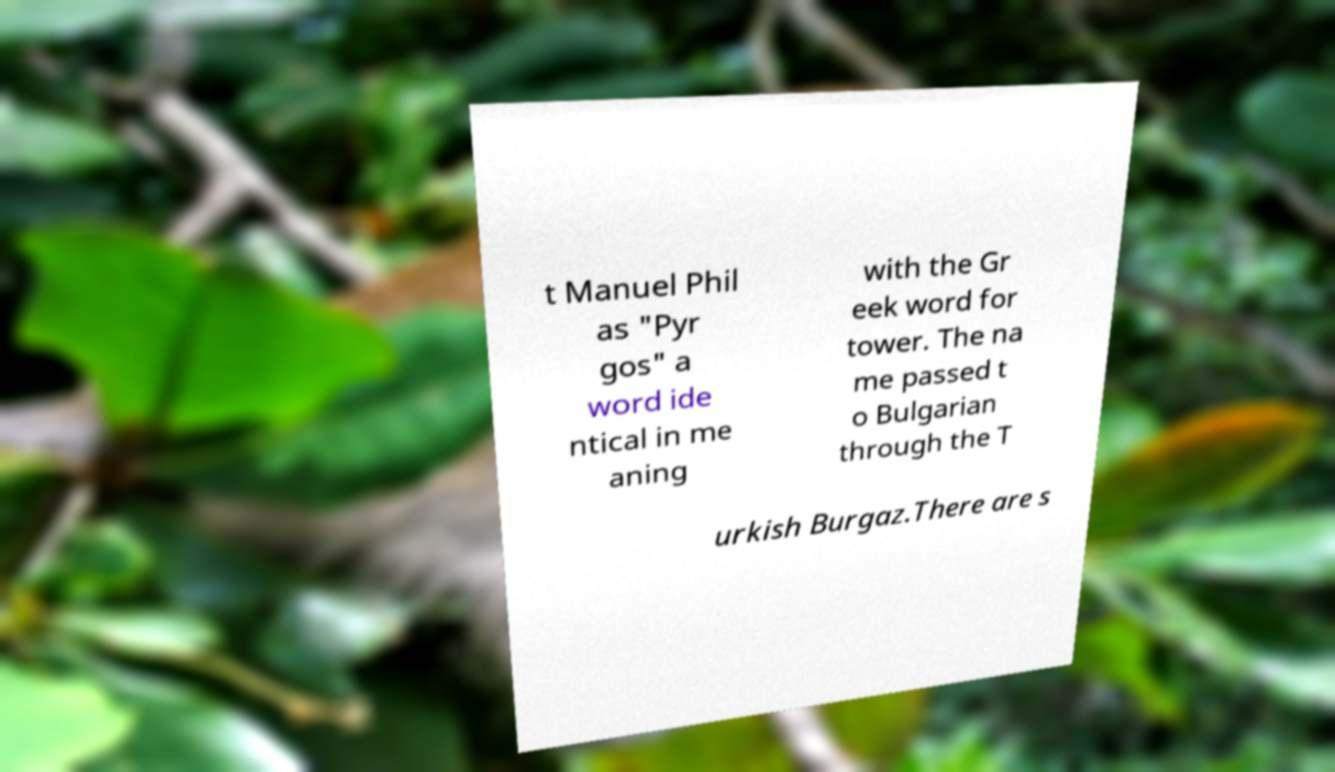I need the written content from this picture converted into text. Can you do that? t Manuel Phil as "Pyr gos" a word ide ntical in me aning with the Gr eek word for tower. The na me passed t o Bulgarian through the T urkish Burgaz.There are s 